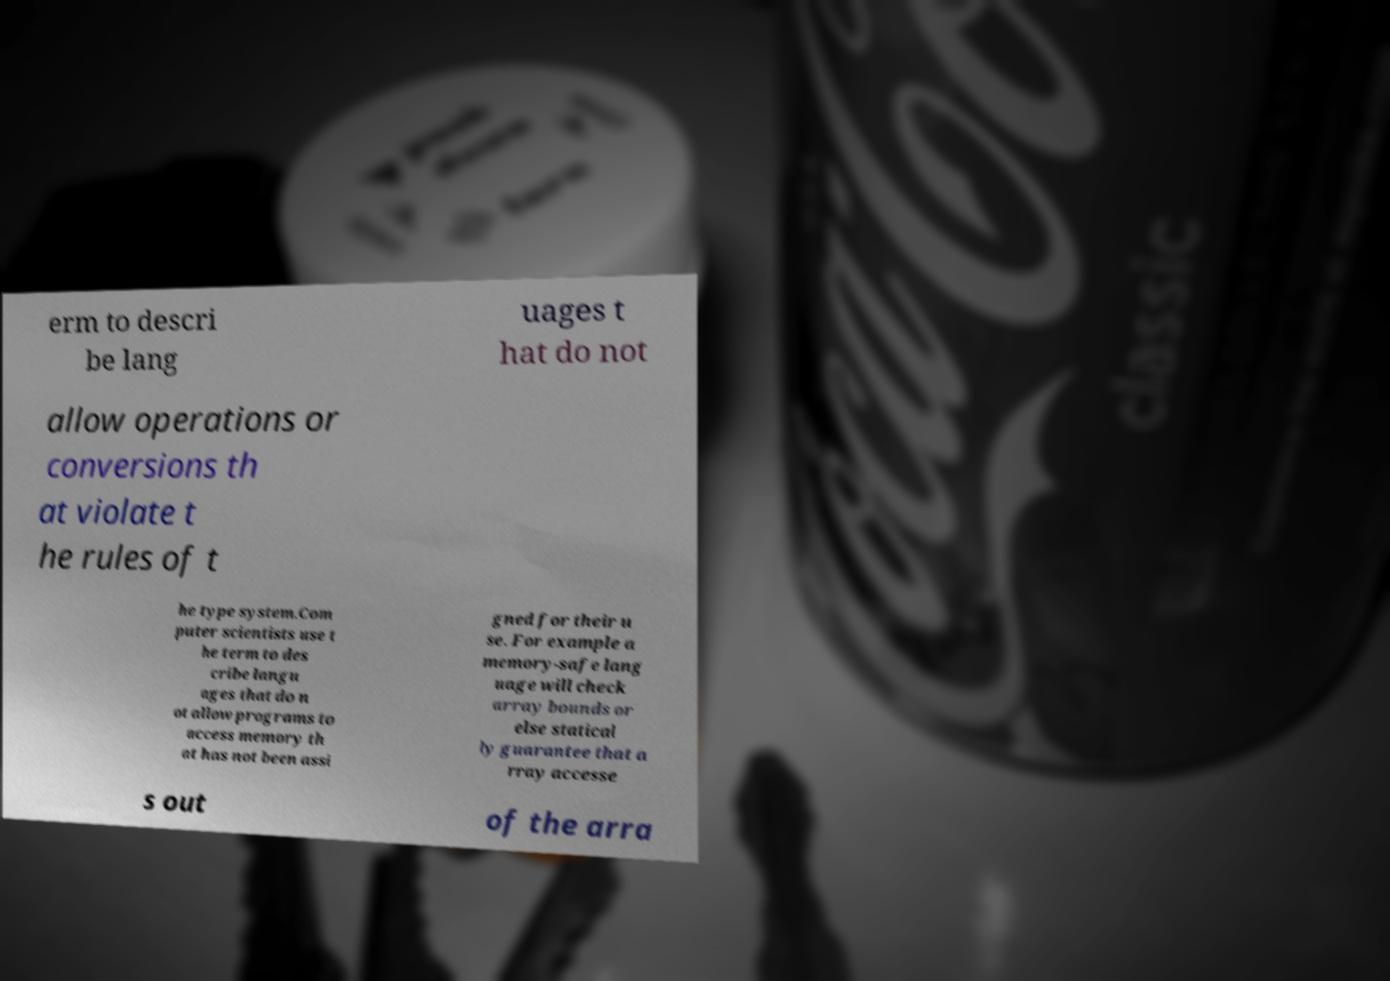I need the written content from this picture converted into text. Can you do that? erm to descri be lang uages t hat do not allow operations or conversions th at violate t he rules of t he type system.Com puter scientists use t he term to des cribe langu ages that do n ot allow programs to access memory th at has not been assi gned for their u se. For example a memory-safe lang uage will check array bounds or else statical ly guarantee that a rray accesse s out of the arra 